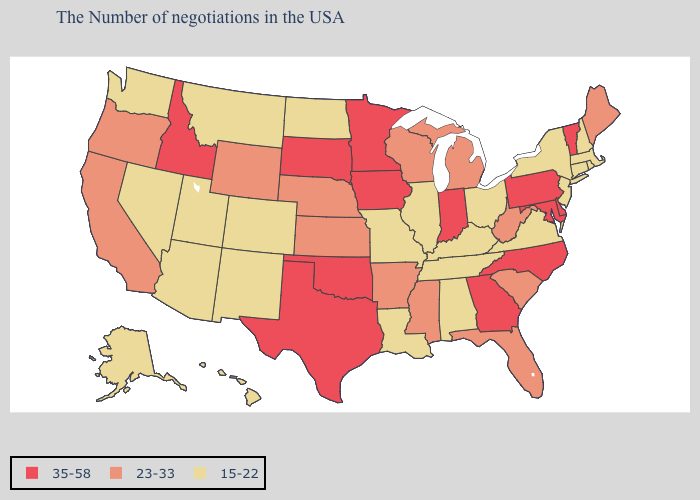Name the states that have a value in the range 23-33?
Give a very brief answer. Maine, South Carolina, West Virginia, Florida, Michigan, Wisconsin, Mississippi, Arkansas, Kansas, Nebraska, Wyoming, California, Oregon. What is the lowest value in the MidWest?
Short answer required. 15-22. Which states have the highest value in the USA?
Quick response, please. Vermont, Delaware, Maryland, Pennsylvania, North Carolina, Georgia, Indiana, Minnesota, Iowa, Oklahoma, Texas, South Dakota, Idaho. What is the value of New Mexico?
Short answer required. 15-22. Name the states that have a value in the range 15-22?
Concise answer only. Massachusetts, Rhode Island, New Hampshire, Connecticut, New York, New Jersey, Virginia, Ohio, Kentucky, Alabama, Tennessee, Illinois, Louisiana, Missouri, North Dakota, Colorado, New Mexico, Utah, Montana, Arizona, Nevada, Washington, Alaska, Hawaii. Does Idaho have the highest value in the West?
Answer briefly. Yes. Among the states that border Maryland , does Delaware have the lowest value?
Answer briefly. No. Which states have the lowest value in the USA?
Be succinct. Massachusetts, Rhode Island, New Hampshire, Connecticut, New York, New Jersey, Virginia, Ohio, Kentucky, Alabama, Tennessee, Illinois, Louisiana, Missouri, North Dakota, Colorado, New Mexico, Utah, Montana, Arizona, Nevada, Washington, Alaska, Hawaii. What is the lowest value in states that border New Mexico?
Write a very short answer. 15-22. Which states hav the highest value in the South?
Give a very brief answer. Delaware, Maryland, North Carolina, Georgia, Oklahoma, Texas. Name the states that have a value in the range 15-22?
Be succinct. Massachusetts, Rhode Island, New Hampshire, Connecticut, New York, New Jersey, Virginia, Ohio, Kentucky, Alabama, Tennessee, Illinois, Louisiana, Missouri, North Dakota, Colorado, New Mexico, Utah, Montana, Arizona, Nevada, Washington, Alaska, Hawaii. Which states have the lowest value in the USA?
Be succinct. Massachusetts, Rhode Island, New Hampshire, Connecticut, New York, New Jersey, Virginia, Ohio, Kentucky, Alabama, Tennessee, Illinois, Louisiana, Missouri, North Dakota, Colorado, New Mexico, Utah, Montana, Arizona, Nevada, Washington, Alaska, Hawaii. What is the lowest value in states that border Minnesota?
Quick response, please. 15-22. Among the states that border New Mexico , which have the lowest value?
Write a very short answer. Colorado, Utah, Arizona. Which states have the highest value in the USA?
Quick response, please. Vermont, Delaware, Maryland, Pennsylvania, North Carolina, Georgia, Indiana, Minnesota, Iowa, Oklahoma, Texas, South Dakota, Idaho. 